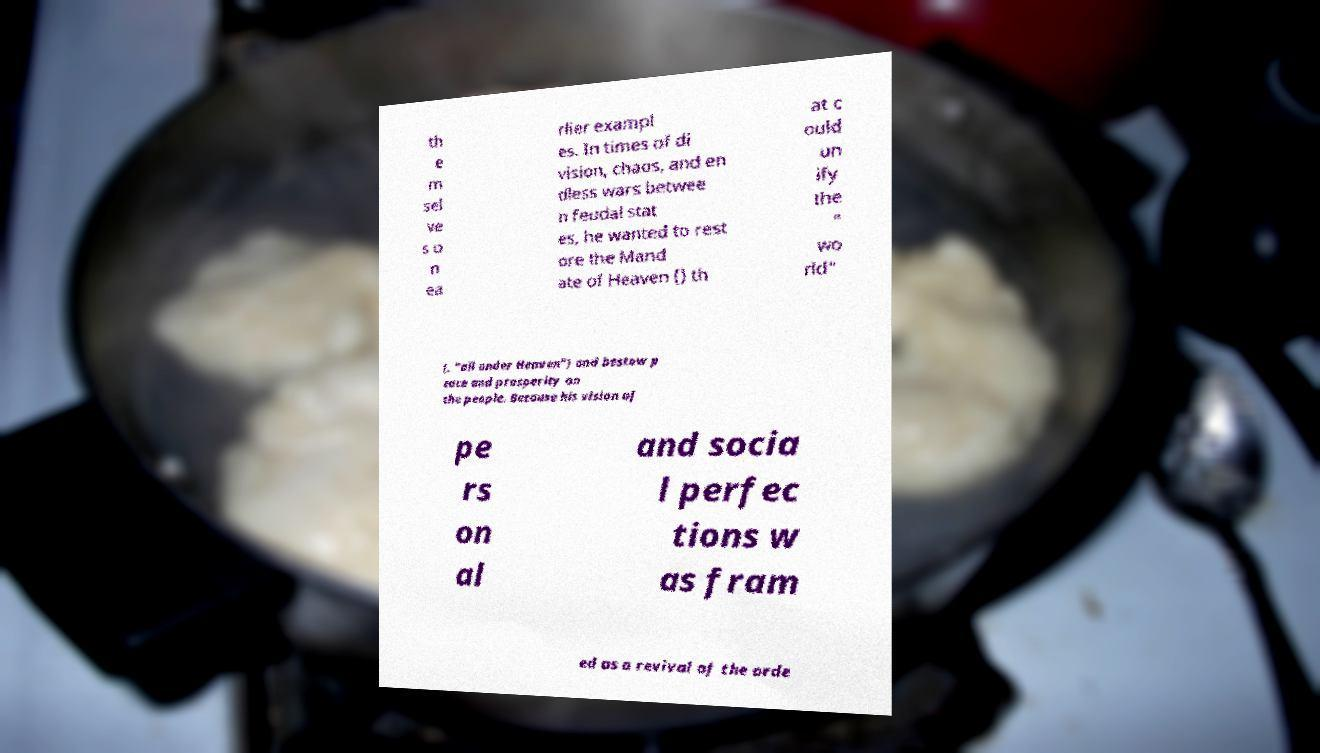For documentation purposes, I need the text within this image transcribed. Could you provide that? th e m sel ve s o n ea rlier exampl es. In times of di vision, chaos, and en dless wars betwee n feudal stat es, he wanted to rest ore the Mand ate of Heaven () th at c ould un ify the " wo rld" (, "all under Heaven") and bestow p eace and prosperity on the people. Because his vision of pe rs on al and socia l perfec tions w as fram ed as a revival of the orde 